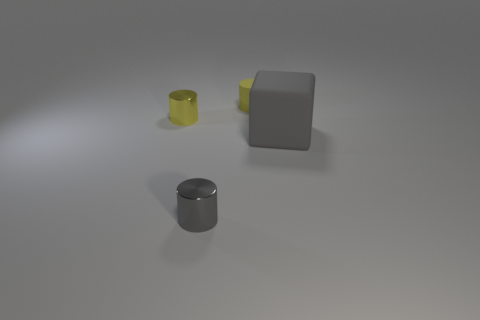Are the tiny yellow cylinder that is behind the small yellow shiny object and the gray object that is on the right side of the yellow rubber cylinder made of the same material?
Ensure brevity in your answer.  Yes. What is the size of the matte thing on the left side of the large gray object?
Offer a very short reply. Small. What is the material of the other tiny gray object that is the same shape as the small matte object?
Provide a succinct answer. Metal. Are there any other things that are the same size as the gray shiny thing?
Provide a short and direct response. Yes. There is a rubber thing that is right of the yellow matte object; what is its shape?
Provide a short and direct response. Cube. What number of tiny metallic things have the same shape as the tiny yellow matte object?
Provide a succinct answer. 2. Are there an equal number of objects that are in front of the yellow matte cylinder and rubber cylinders that are behind the gray matte block?
Provide a succinct answer. No. Are there any tiny cylinders that have the same material as the large gray thing?
Keep it short and to the point. Yes. Is the gray cylinder made of the same material as the gray block?
Your answer should be compact. No. How many gray things are small objects or large cubes?
Ensure brevity in your answer.  2. 